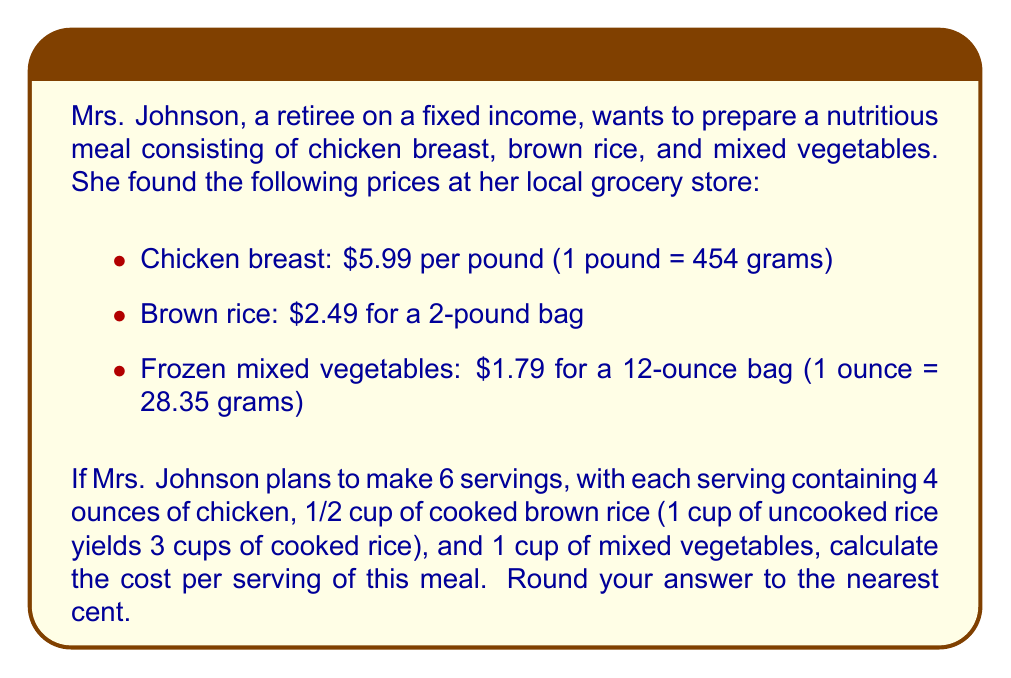Teach me how to tackle this problem. Let's break this down step-by-step:

1. Calculate the cost of chicken per serving:
   - 4 ounces = 113.4 grams
   - Cost per gram = $5.99 / 454 = $0.0132 per gram
   - Cost per serving = 113.4 * $0.0132 = $1.49

2. Calculate the cost of brown rice per serving:
   - 1/2 cup cooked rice = 1/6 cup uncooked rice
   - 2 pounds of rice = 907 grams
   - Cost per gram = $2.49 / 907 = $0.00275 per gram
   - 1 cup of uncooked rice ≈ 190 grams
   - Cost per serving = (190 / 6) * $0.00275 = $0.09

3. Calculate the cost of mixed vegetables per serving:
   - 1 cup = 8 ounces = 226.8 grams
   - Cost per gram = $1.79 / (12 * 28.35) = $0.00526 per gram
   - Cost per serving = 226.8 * $0.00526 = $1.19

4. Calculate the total cost per serving:
   $$ \text{Cost per serving} = $1.49 + $0.09 + $1.19 = $2.77 $$

5. Round to the nearest cent:
   $$ \text{Rounded cost per serving} = $2.77 $$
Answer: $2.77 per serving 